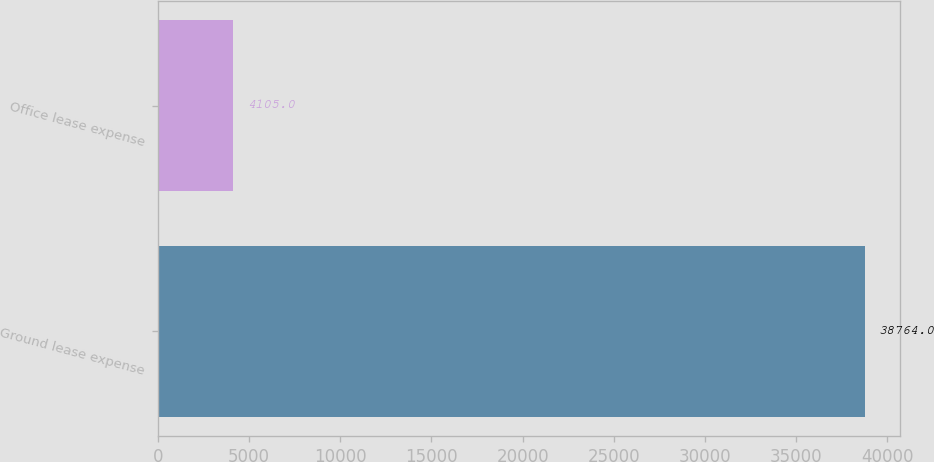Convert chart. <chart><loc_0><loc_0><loc_500><loc_500><bar_chart><fcel>Ground lease expense<fcel>Office lease expense<nl><fcel>38764<fcel>4105<nl></chart> 